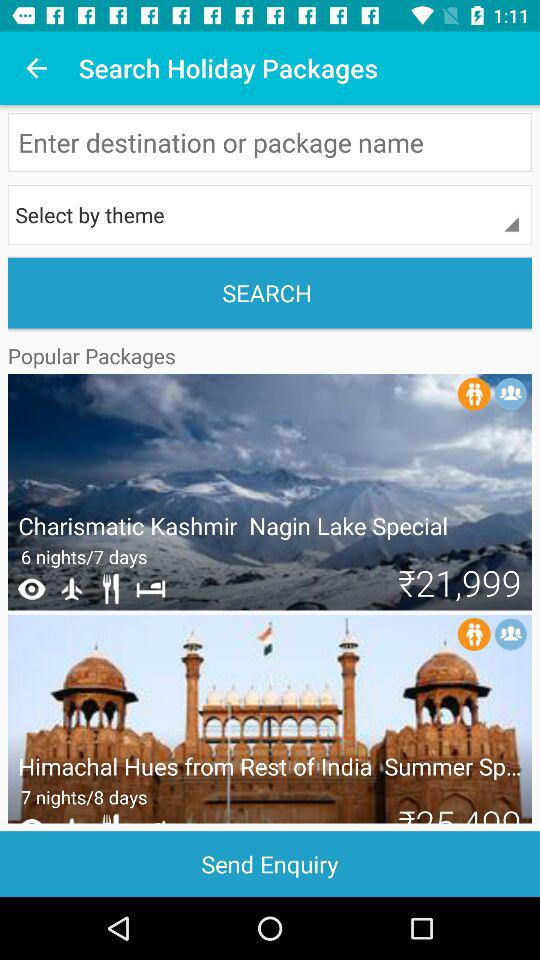Which package has a 6-night trip planned? The package that has a 6-night trip planned is "Charismatic Kashmir Nagin Lake Special". 